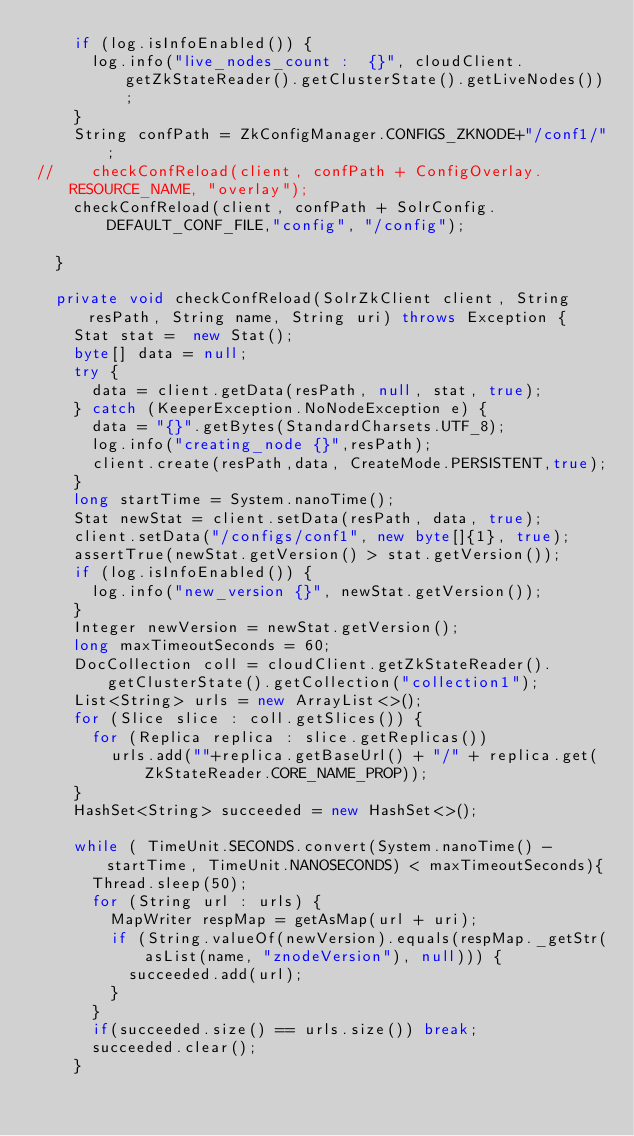<code> <loc_0><loc_0><loc_500><loc_500><_Java_>    if (log.isInfoEnabled()) {
      log.info("live_nodes_count :  {}", cloudClient.getZkStateReader().getClusterState().getLiveNodes());
    }
    String confPath = ZkConfigManager.CONFIGS_ZKNODE+"/conf1/";
//    checkConfReload(client, confPath + ConfigOverlay.RESOURCE_NAME, "overlay");
    checkConfReload(client, confPath + SolrConfig.DEFAULT_CONF_FILE,"config", "/config");

  }

  private void checkConfReload(SolrZkClient client, String resPath, String name, String uri) throws Exception {
    Stat stat =  new Stat();
    byte[] data = null;
    try {
      data = client.getData(resPath, null, stat, true);
    } catch (KeeperException.NoNodeException e) {
      data = "{}".getBytes(StandardCharsets.UTF_8);
      log.info("creating_node {}",resPath);
      client.create(resPath,data, CreateMode.PERSISTENT,true);
    }
    long startTime = System.nanoTime();
    Stat newStat = client.setData(resPath, data, true);
    client.setData("/configs/conf1", new byte[]{1}, true);
    assertTrue(newStat.getVersion() > stat.getVersion());
    if (log.isInfoEnabled()) {
      log.info("new_version {}", newStat.getVersion());
    }
    Integer newVersion = newStat.getVersion();
    long maxTimeoutSeconds = 60;
    DocCollection coll = cloudClient.getZkStateReader().getClusterState().getCollection("collection1");
    List<String> urls = new ArrayList<>();
    for (Slice slice : coll.getSlices()) {
      for (Replica replica : slice.getReplicas())
        urls.add(""+replica.getBaseUrl() + "/" + replica.get(ZkStateReader.CORE_NAME_PROP));
    }
    HashSet<String> succeeded = new HashSet<>();

    while ( TimeUnit.SECONDS.convert(System.nanoTime() - startTime, TimeUnit.NANOSECONDS) < maxTimeoutSeconds){
      Thread.sleep(50);
      for (String url : urls) {
        MapWriter respMap = getAsMap(url + uri);
        if (String.valueOf(newVersion).equals(respMap._getStr(asList(name, "znodeVersion"), null))) {
          succeeded.add(url);
        }
      }
      if(succeeded.size() == urls.size()) break;
      succeeded.clear();
    }</code> 